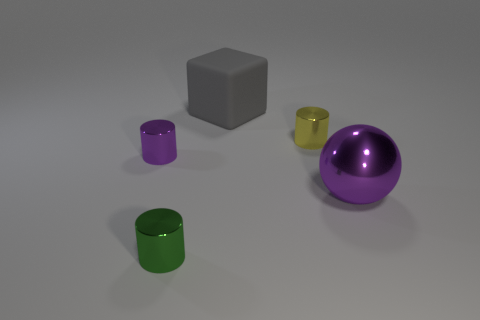Can you describe the positioning of the objects in relation to each other? The objects are arranged with the three cylinders at varying distances from the front of the scene, followed by the grey cube, and finally the purple ball at the back. This creates a sense of depth and layering, with the purple ball acting as a focal point due to its size and position. 